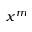Convert formula to latex. <formula><loc_0><loc_0><loc_500><loc_500>x ^ { m }</formula> 